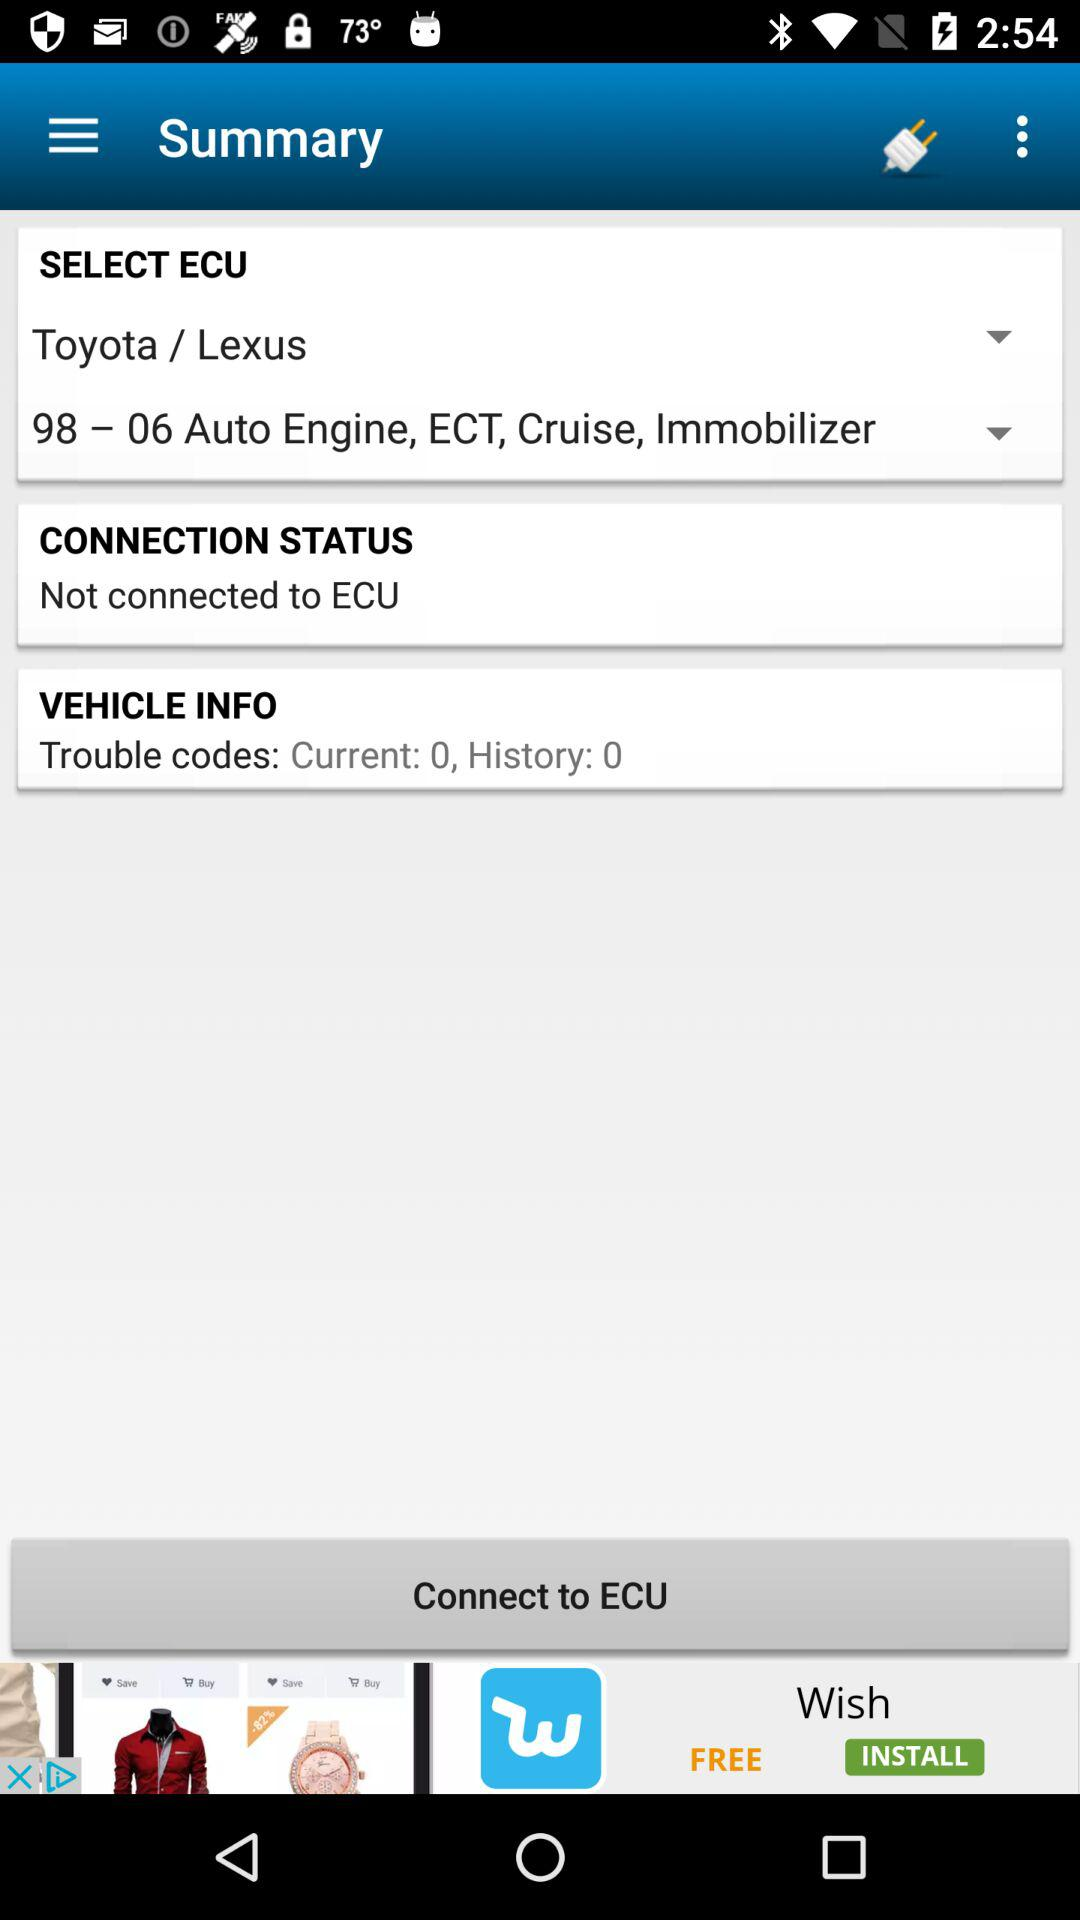What is the connection status? The connection status is not connected to the ECU. 